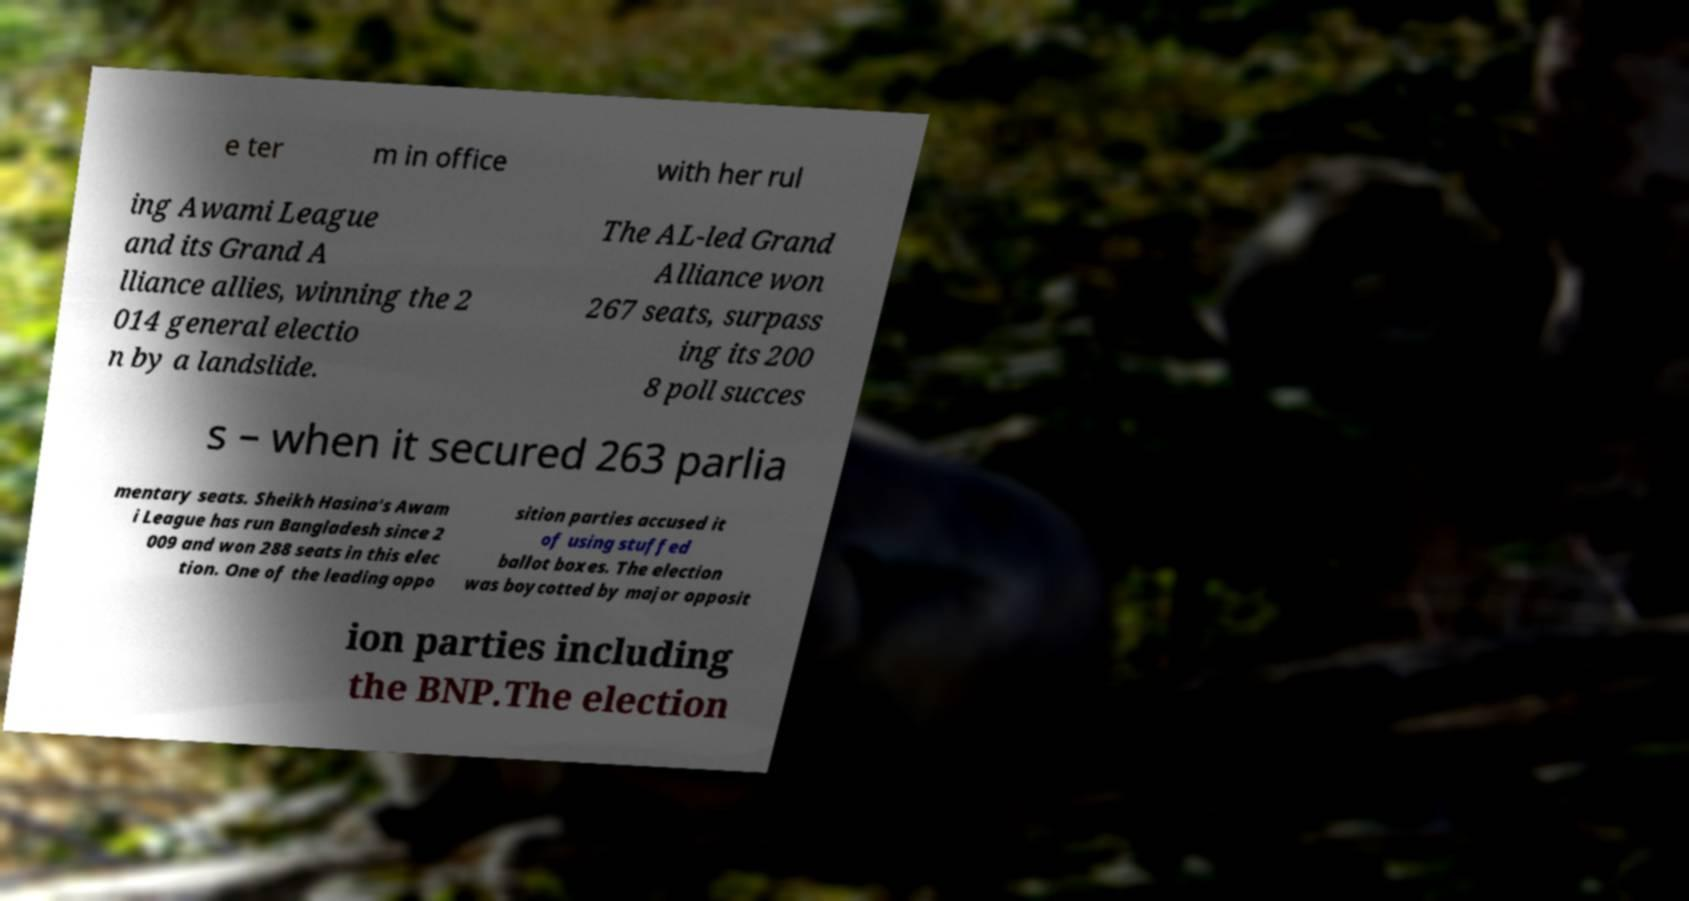There's text embedded in this image that I need extracted. Can you transcribe it verbatim? e ter m in office with her rul ing Awami League and its Grand A lliance allies, winning the 2 014 general electio n by a landslide. The AL-led Grand Alliance won 267 seats, surpass ing its 200 8 poll succes s – when it secured 263 parlia mentary seats. Sheikh Hasina's Awam i League has run Bangladesh since 2 009 and won 288 seats in this elec tion. One of the leading oppo sition parties accused it of using stuffed ballot boxes. The election was boycotted by major opposit ion parties including the BNP.The election 